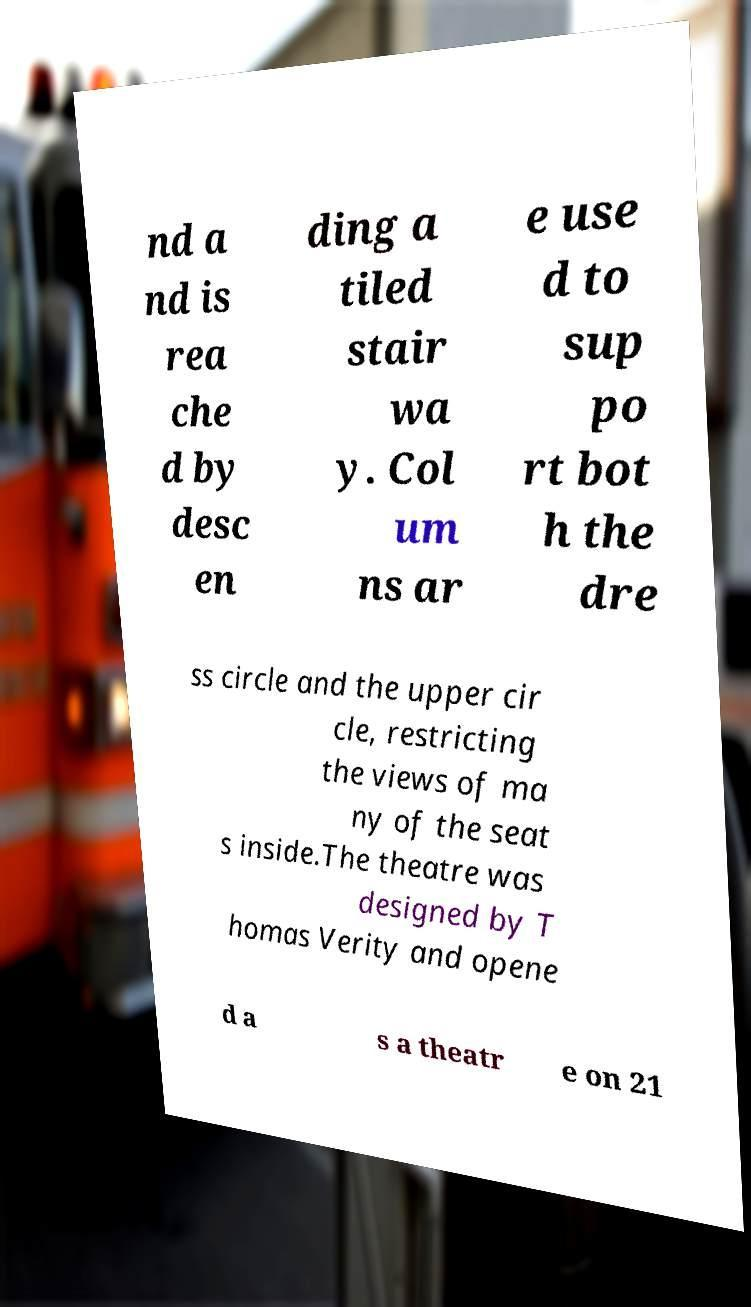There's text embedded in this image that I need extracted. Can you transcribe it verbatim? nd a nd is rea che d by desc en ding a tiled stair wa y. Col um ns ar e use d to sup po rt bot h the dre ss circle and the upper cir cle, restricting the views of ma ny of the seat s inside.The theatre was designed by T homas Verity and opene d a s a theatr e on 21 